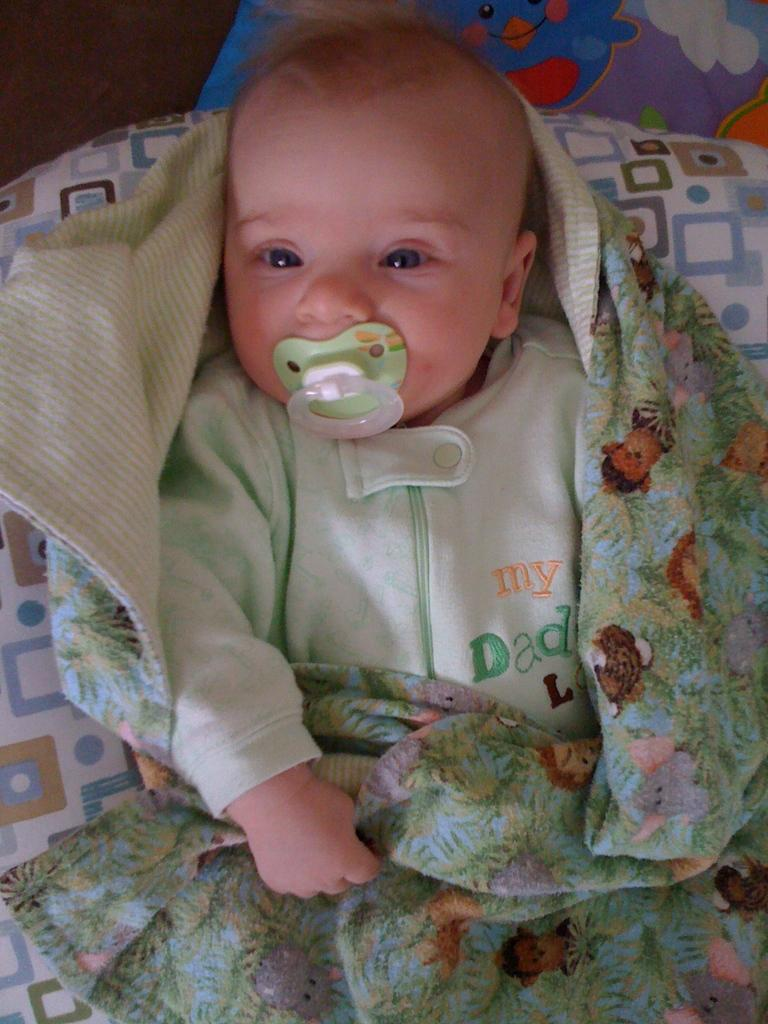What is the main subject of the image? The main subject of the image is a baby. Where is the baby located in the image? The baby is lying in a bed. What is covering the bed in the image? The bed has a sheet. What is the baby holding or using in the image? The baby has a nipple or soother in his mouth. What type of plastic material can be seen on the trail in the image? There is no trail or plastic material present in the image; it features a baby lying in a bed. 